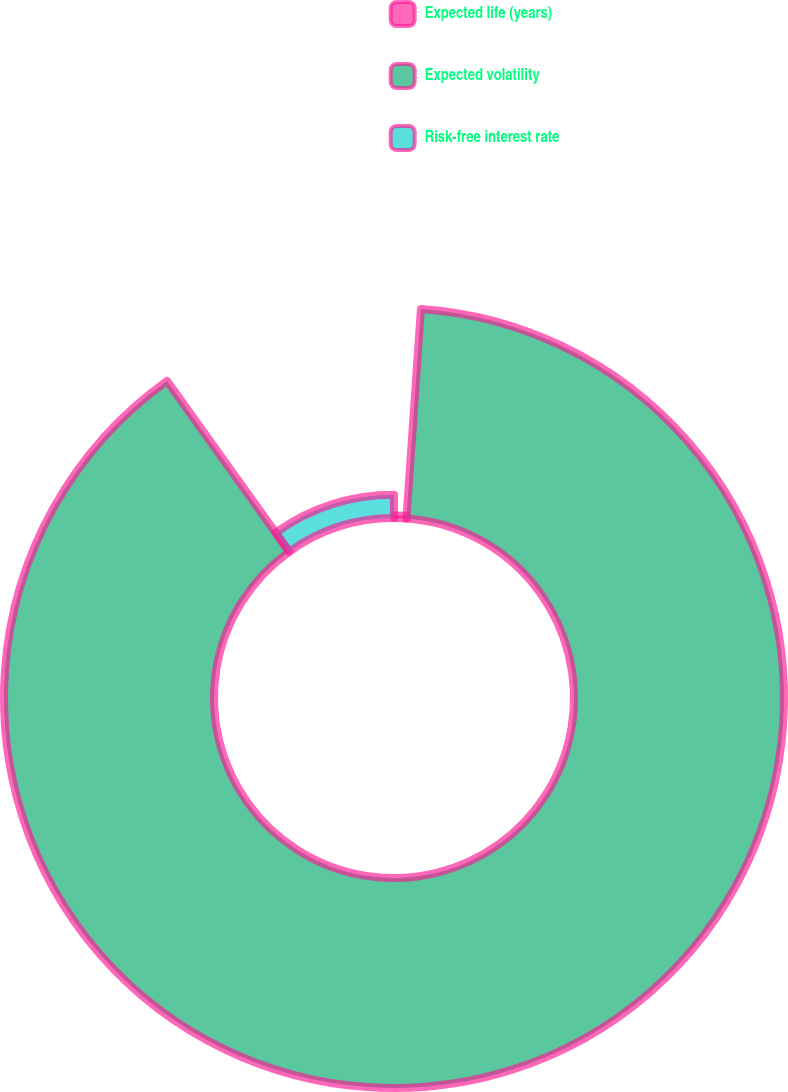<chart> <loc_0><loc_0><loc_500><loc_500><pie_chart><fcel>Expected life (years)<fcel>Expected volatility<fcel>Risk-free interest rate<nl><fcel>1.1%<fcel>89.02%<fcel>9.89%<nl></chart> 